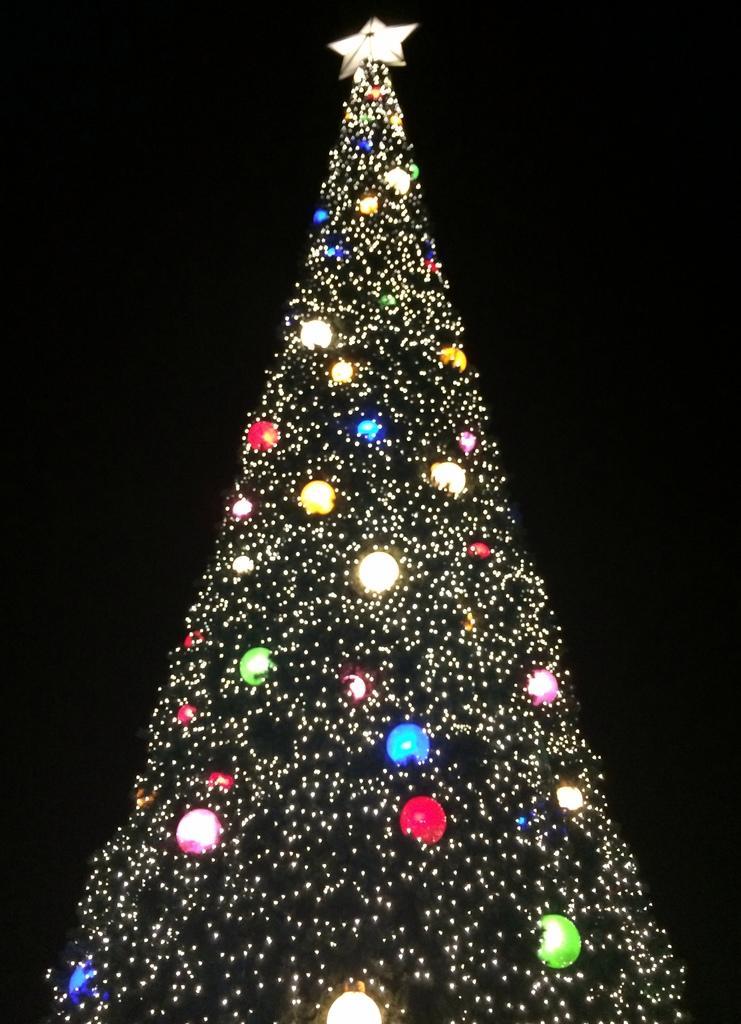How would you summarize this image in a sentence or two? This image consists of a Xmas tree made up of lights. At the top, we can see a star. The background is too dark. 